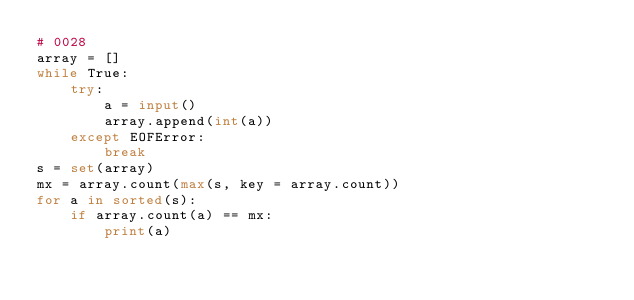<code> <loc_0><loc_0><loc_500><loc_500><_Python_># 0028
array = []
while True:
    try:
        a = input()
        array.append(int(a))
    except EOFError:
        break
s = set(array)
mx = array.count(max(s, key = array.count))
for a in sorted(s):
    if array.count(a) == mx:
        print(a)</code> 